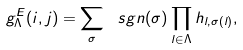Convert formula to latex. <formula><loc_0><loc_0><loc_500><loc_500>g _ { \Lambda } ^ { E } ( i , j ) = \sum _ { \sigma } \ s g n ( \sigma ) \prod _ { l \in \Lambda } h _ { l , \sigma ( l ) } ,</formula> 